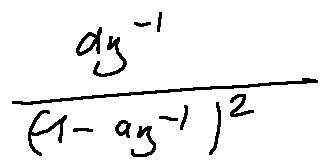Convert formula to latex. <formula><loc_0><loc_0><loc_500><loc_500>\frac { a z ^ { - 1 } } { ( 1 - a z ^ { - 1 } ) ^ { 2 } }</formula> 